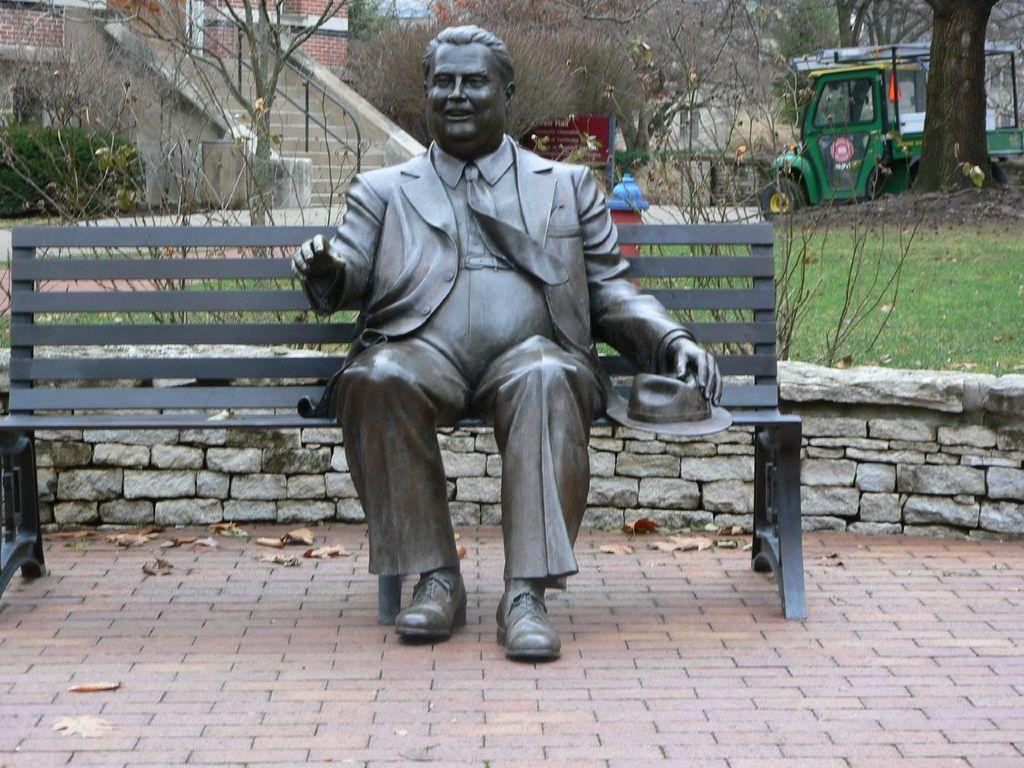What is the main subject of the image? There is a sculpture of a man in the image. What is the sculpture doing in the image? The sculpture is sitting on a bench. What can be seen in the background of the image? There is a vehicle and trees in the background of the image. What type of jar is being used to create harmony in the image? There is no jar or mention of harmony in the image; it features a sculpture sitting on a bench with a vehicle and trees in the background. 